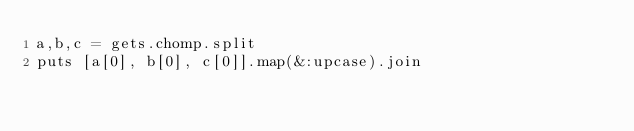<code> <loc_0><loc_0><loc_500><loc_500><_Ruby_>a,b,c = gets.chomp.split
puts [a[0], b[0], c[0]].map(&:upcase).join
</code> 